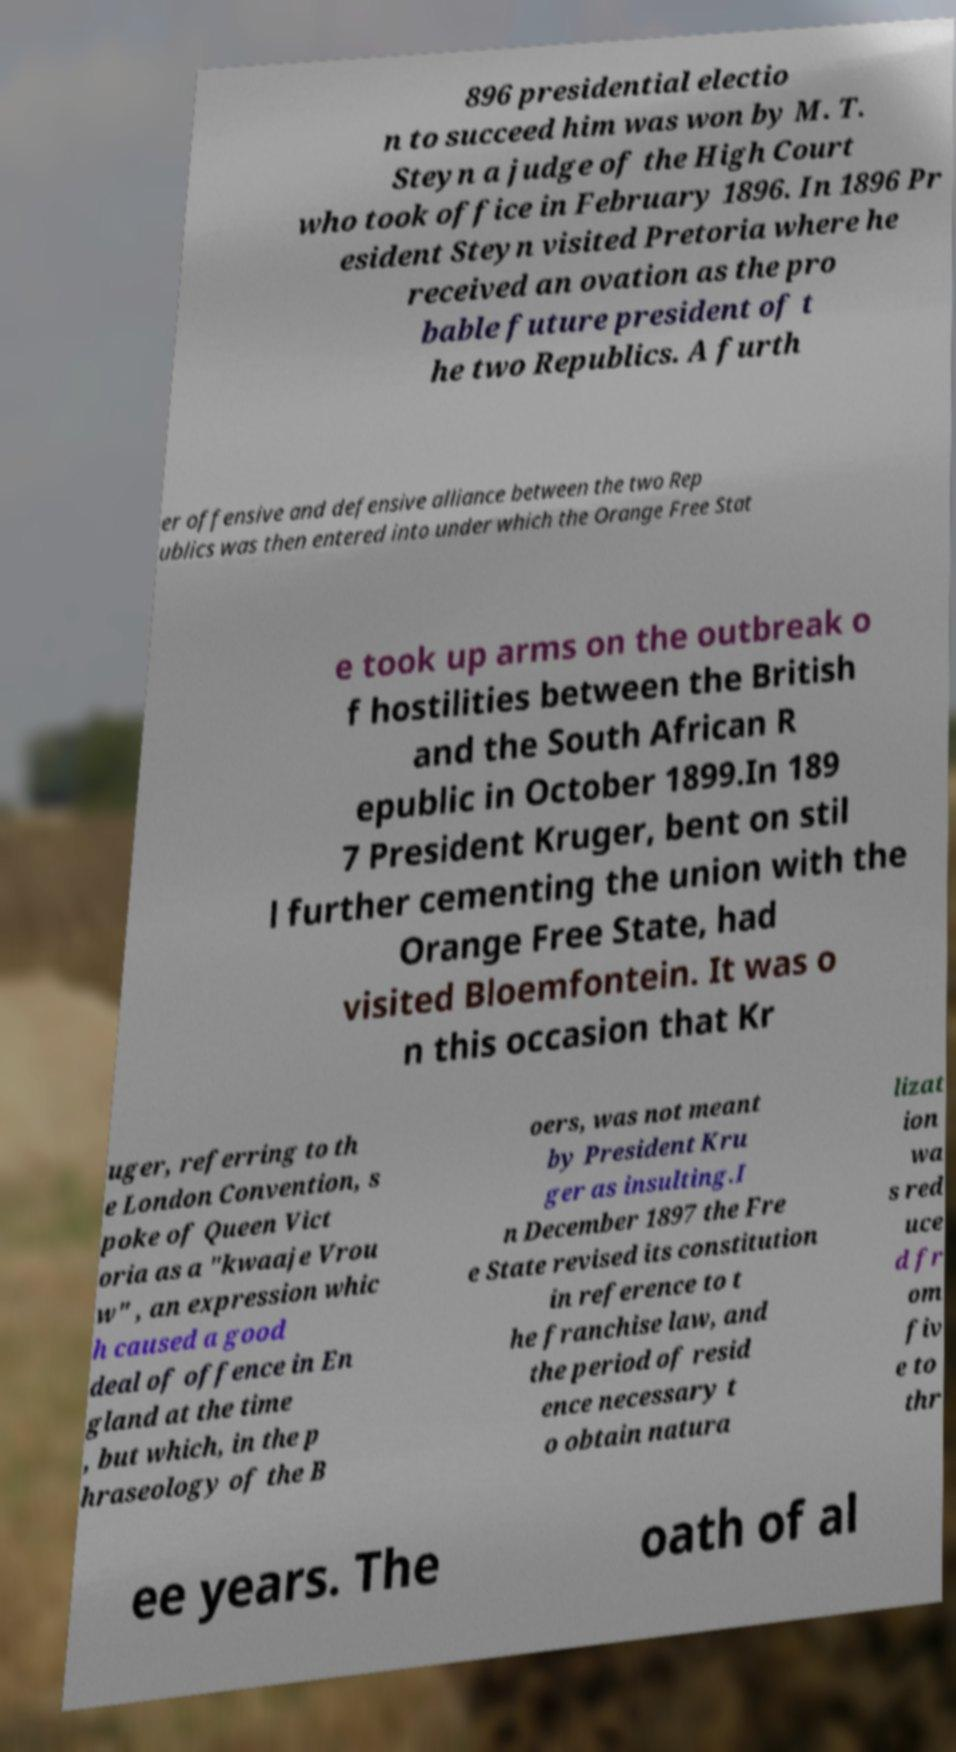Could you extract and type out the text from this image? 896 presidential electio n to succeed him was won by M. T. Steyn a judge of the High Court who took office in February 1896. In 1896 Pr esident Steyn visited Pretoria where he received an ovation as the pro bable future president of t he two Republics. A furth er offensive and defensive alliance between the two Rep ublics was then entered into under which the Orange Free Stat e took up arms on the outbreak o f hostilities between the British and the South African R epublic in October 1899.In 189 7 President Kruger, bent on stil l further cementing the union with the Orange Free State, had visited Bloemfontein. It was o n this occasion that Kr uger, referring to th e London Convention, s poke of Queen Vict oria as a "kwaaje Vrou w" , an expression whic h caused a good deal of offence in En gland at the time , but which, in the p hraseology of the B oers, was not meant by President Kru ger as insulting.I n December 1897 the Fre e State revised its constitution in reference to t he franchise law, and the period of resid ence necessary t o obtain natura lizat ion wa s red uce d fr om fiv e to thr ee years. The oath of al 